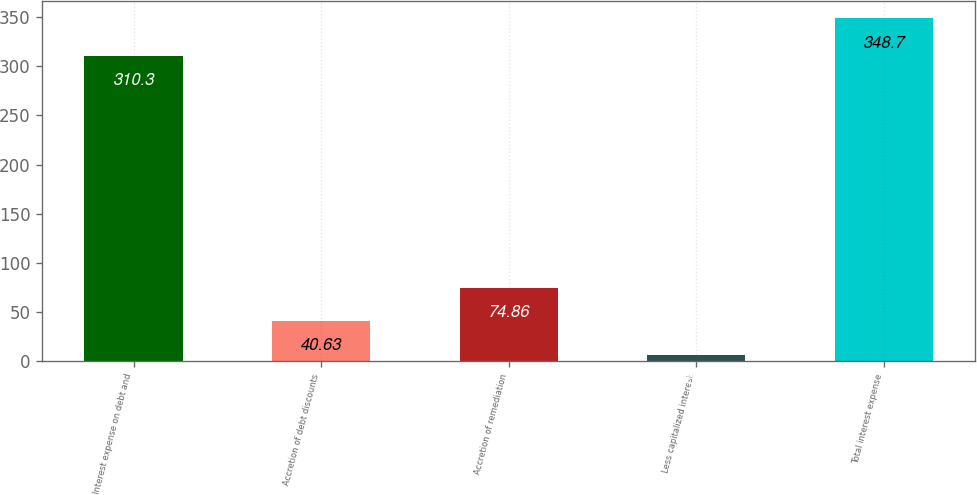Convert chart to OTSL. <chart><loc_0><loc_0><loc_500><loc_500><bar_chart><fcel>Interest expense on debt and<fcel>Accretion of debt discounts<fcel>Accretion of remediation<fcel>Less capitalized interest<fcel>Total interest expense<nl><fcel>310.3<fcel>40.63<fcel>74.86<fcel>6.4<fcel>348.7<nl></chart> 